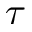Convert formula to latex. <formula><loc_0><loc_0><loc_500><loc_500>\tau</formula> 